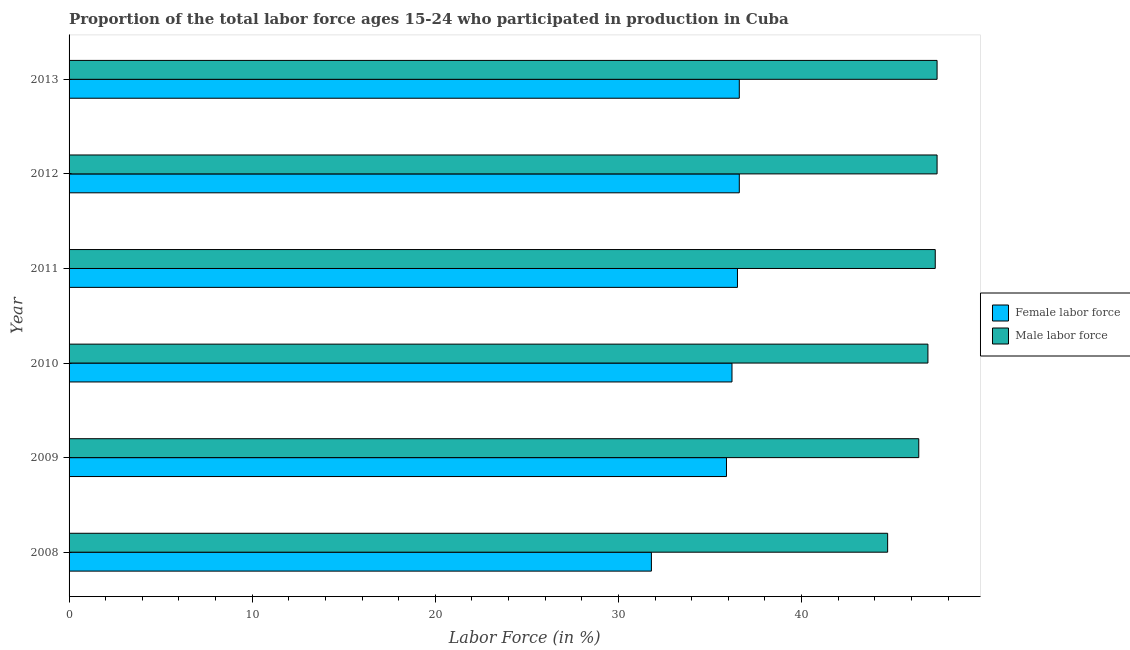How many different coloured bars are there?
Your response must be concise. 2. How many groups of bars are there?
Your answer should be compact. 6. Are the number of bars on each tick of the Y-axis equal?
Your response must be concise. Yes. What is the percentage of female labor force in 2011?
Provide a short and direct response. 36.5. Across all years, what is the maximum percentage of male labour force?
Your response must be concise. 47.4. Across all years, what is the minimum percentage of male labour force?
Offer a very short reply. 44.7. In which year was the percentage of female labor force minimum?
Your answer should be compact. 2008. What is the total percentage of female labor force in the graph?
Offer a terse response. 213.6. What is the difference between the percentage of male labour force in 2009 and the percentage of female labor force in 2008?
Ensure brevity in your answer.  14.6. What is the average percentage of male labour force per year?
Your response must be concise. 46.68. In the year 2009, what is the difference between the percentage of male labour force and percentage of female labor force?
Ensure brevity in your answer.  10.5. In how many years, is the percentage of female labor force greater than 16 %?
Ensure brevity in your answer.  6. What is the ratio of the percentage of male labour force in 2008 to that in 2012?
Keep it short and to the point. 0.94. What is the difference between the highest and the second highest percentage of female labor force?
Your answer should be compact. 0. What is the difference between the highest and the lowest percentage of male labour force?
Offer a terse response. 2.7. Is the sum of the percentage of female labor force in 2009 and 2012 greater than the maximum percentage of male labour force across all years?
Ensure brevity in your answer.  Yes. What does the 2nd bar from the top in 2009 represents?
Your answer should be very brief. Female labor force. What does the 2nd bar from the bottom in 2013 represents?
Ensure brevity in your answer.  Male labor force. How many bars are there?
Give a very brief answer. 12. How many years are there in the graph?
Your answer should be very brief. 6. What is the difference between two consecutive major ticks on the X-axis?
Offer a very short reply. 10. What is the title of the graph?
Your answer should be compact. Proportion of the total labor force ages 15-24 who participated in production in Cuba. What is the label or title of the Y-axis?
Make the answer very short. Year. What is the Labor Force (in %) of Female labor force in 2008?
Provide a succinct answer. 31.8. What is the Labor Force (in %) in Male labor force in 2008?
Your response must be concise. 44.7. What is the Labor Force (in %) in Female labor force in 2009?
Your response must be concise. 35.9. What is the Labor Force (in %) of Male labor force in 2009?
Keep it short and to the point. 46.4. What is the Labor Force (in %) of Female labor force in 2010?
Give a very brief answer. 36.2. What is the Labor Force (in %) of Male labor force in 2010?
Offer a terse response. 46.9. What is the Labor Force (in %) of Female labor force in 2011?
Your response must be concise. 36.5. What is the Labor Force (in %) of Male labor force in 2011?
Give a very brief answer. 47.3. What is the Labor Force (in %) in Female labor force in 2012?
Give a very brief answer. 36.6. What is the Labor Force (in %) in Male labor force in 2012?
Offer a very short reply. 47.4. What is the Labor Force (in %) in Female labor force in 2013?
Give a very brief answer. 36.6. What is the Labor Force (in %) of Male labor force in 2013?
Keep it short and to the point. 47.4. Across all years, what is the maximum Labor Force (in %) of Female labor force?
Ensure brevity in your answer.  36.6. Across all years, what is the maximum Labor Force (in %) of Male labor force?
Your answer should be very brief. 47.4. Across all years, what is the minimum Labor Force (in %) of Female labor force?
Your response must be concise. 31.8. Across all years, what is the minimum Labor Force (in %) in Male labor force?
Keep it short and to the point. 44.7. What is the total Labor Force (in %) of Female labor force in the graph?
Your response must be concise. 213.6. What is the total Labor Force (in %) of Male labor force in the graph?
Your response must be concise. 280.1. What is the difference between the Labor Force (in %) in Female labor force in 2008 and that in 2009?
Make the answer very short. -4.1. What is the difference between the Labor Force (in %) in Male labor force in 2008 and that in 2009?
Make the answer very short. -1.7. What is the difference between the Labor Force (in %) of Male labor force in 2008 and that in 2012?
Keep it short and to the point. -2.7. What is the difference between the Labor Force (in %) in Male labor force in 2008 and that in 2013?
Your answer should be very brief. -2.7. What is the difference between the Labor Force (in %) of Male labor force in 2009 and that in 2012?
Your answer should be very brief. -1. What is the difference between the Labor Force (in %) of Female labor force in 2010 and that in 2011?
Your response must be concise. -0.3. What is the difference between the Labor Force (in %) in Female labor force in 2010 and that in 2013?
Provide a short and direct response. -0.4. What is the difference between the Labor Force (in %) of Male labor force in 2010 and that in 2013?
Offer a terse response. -0.5. What is the difference between the Labor Force (in %) of Male labor force in 2011 and that in 2012?
Your answer should be very brief. -0.1. What is the difference between the Labor Force (in %) of Female labor force in 2012 and that in 2013?
Offer a very short reply. 0. What is the difference between the Labor Force (in %) of Female labor force in 2008 and the Labor Force (in %) of Male labor force in 2009?
Give a very brief answer. -14.6. What is the difference between the Labor Force (in %) in Female labor force in 2008 and the Labor Force (in %) in Male labor force in 2010?
Give a very brief answer. -15.1. What is the difference between the Labor Force (in %) of Female labor force in 2008 and the Labor Force (in %) of Male labor force in 2011?
Your answer should be compact. -15.5. What is the difference between the Labor Force (in %) in Female labor force in 2008 and the Labor Force (in %) in Male labor force in 2012?
Your response must be concise. -15.6. What is the difference between the Labor Force (in %) of Female labor force in 2008 and the Labor Force (in %) of Male labor force in 2013?
Provide a short and direct response. -15.6. What is the difference between the Labor Force (in %) of Female labor force in 2009 and the Labor Force (in %) of Male labor force in 2010?
Make the answer very short. -11. What is the difference between the Labor Force (in %) in Female labor force in 2009 and the Labor Force (in %) in Male labor force in 2012?
Give a very brief answer. -11.5. What is the difference between the Labor Force (in %) in Female labor force in 2009 and the Labor Force (in %) in Male labor force in 2013?
Make the answer very short. -11.5. What is the difference between the Labor Force (in %) in Female labor force in 2011 and the Labor Force (in %) in Male labor force in 2013?
Keep it short and to the point. -10.9. What is the average Labor Force (in %) in Female labor force per year?
Your answer should be very brief. 35.6. What is the average Labor Force (in %) of Male labor force per year?
Give a very brief answer. 46.68. In the year 2008, what is the difference between the Labor Force (in %) of Female labor force and Labor Force (in %) of Male labor force?
Offer a very short reply. -12.9. In the year 2010, what is the difference between the Labor Force (in %) of Female labor force and Labor Force (in %) of Male labor force?
Offer a terse response. -10.7. In the year 2011, what is the difference between the Labor Force (in %) in Female labor force and Labor Force (in %) in Male labor force?
Make the answer very short. -10.8. In the year 2012, what is the difference between the Labor Force (in %) of Female labor force and Labor Force (in %) of Male labor force?
Offer a terse response. -10.8. What is the ratio of the Labor Force (in %) in Female labor force in 2008 to that in 2009?
Ensure brevity in your answer.  0.89. What is the ratio of the Labor Force (in %) in Male labor force in 2008 to that in 2009?
Ensure brevity in your answer.  0.96. What is the ratio of the Labor Force (in %) in Female labor force in 2008 to that in 2010?
Offer a very short reply. 0.88. What is the ratio of the Labor Force (in %) of Male labor force in 2008 to that in 2010?
Your response must be concise. 0.95. What is the ratio of the Labor Force (in %) of Female labor force in 2008 to that in 2011?
Offer a terse response. 0.87. What is the ratio of the Labor Force (in %) in Male labor force in 2008 to that in 2011?
Offer a terse response. 0.94. What is the ratio of the Labor Force (in %) of Female labor force in 2008 to that in 2012?
Offer a terse response. 0.87. What is the ratio of the Labor Force (in %) of Male labor force in 2008 to that in 2012?
Provide a succinct answer. 0.94. What is the ratio of the Labor Force (in %) of Female labor force in 2008 to that in 2013?
Make the answer very short. 0.87. What is the ratio of the Labor Force (in %) in Male labor force in 2008 to that in 2013?
Your response must be concise. 0.94. What is the ratio of the Labor Force (in %) of Male labor force in 2009 to that in 2010?
Ensure brevity in your answer.  0.99. What is the ratio of the Labor Force (in %) of Female labor force in 2009 to that in 2011?
Your answer should be compact. 0.98. What is the ratio of the Labor Force (in %) of Male labor force in 2009 to that in 2011?
Provide a succinct answer. 0.98. What is the ratio of the Labor Force (in %) of Female labor force in 2009 to that in 2012?
Offer a terse response. 0.98. What is the ratio of the Labor Force (in %) of Male labor force in 2009 to that in 2012?
Your answer should be compact. 0.98. What is the ratio of the Labor Force (in %) in Female labor force in 2009 to that in 2013?
Make the answer very short. 0.98. What is the ratio of the Labor Force (in %) in Male labor force in 2009 to that in 2013?
Ensure brevity in your answer.  0.98. What is the ratio of the Labor Force (in %) of Female labor force in 2010 to that in 2011?
Provide a succinct answer. 0.99. What is the ratio of the Labor Force (in %) in Female labor force in 2010 to that in 2012?
Make the answer very short. 0.99. What is the ratio of the Labor Force (in %) in Female labor force in 2011 to that in 2012?
Provide a succinct answer. 1. What is the ratio of the Labor Force (in %) of Male labor force in 2011 to that in 2012?
Give a very brief answer. 1. What is the ratio of the Labor Force (in %) of Female labor force in 2011 to that in 2013?
Ensure brevity in your answer.  1. What is the ratio of the Labor Force (in %) of Male labor force in 2011 to that in 2013?
Your response must be concise. 1. What is the difference between the highest and the second highest Labor Force (in %) of Female labor force?
Provide a short and direct response. 0. What is the difference between the highest and the lowest Labor Force (in %) of Female labor force?
Offer a terse response. 4.8. What is the difference between the highest and the lowest Labor Force (in %) of Male labor force?
Provide a short and direct response. 2.7. 